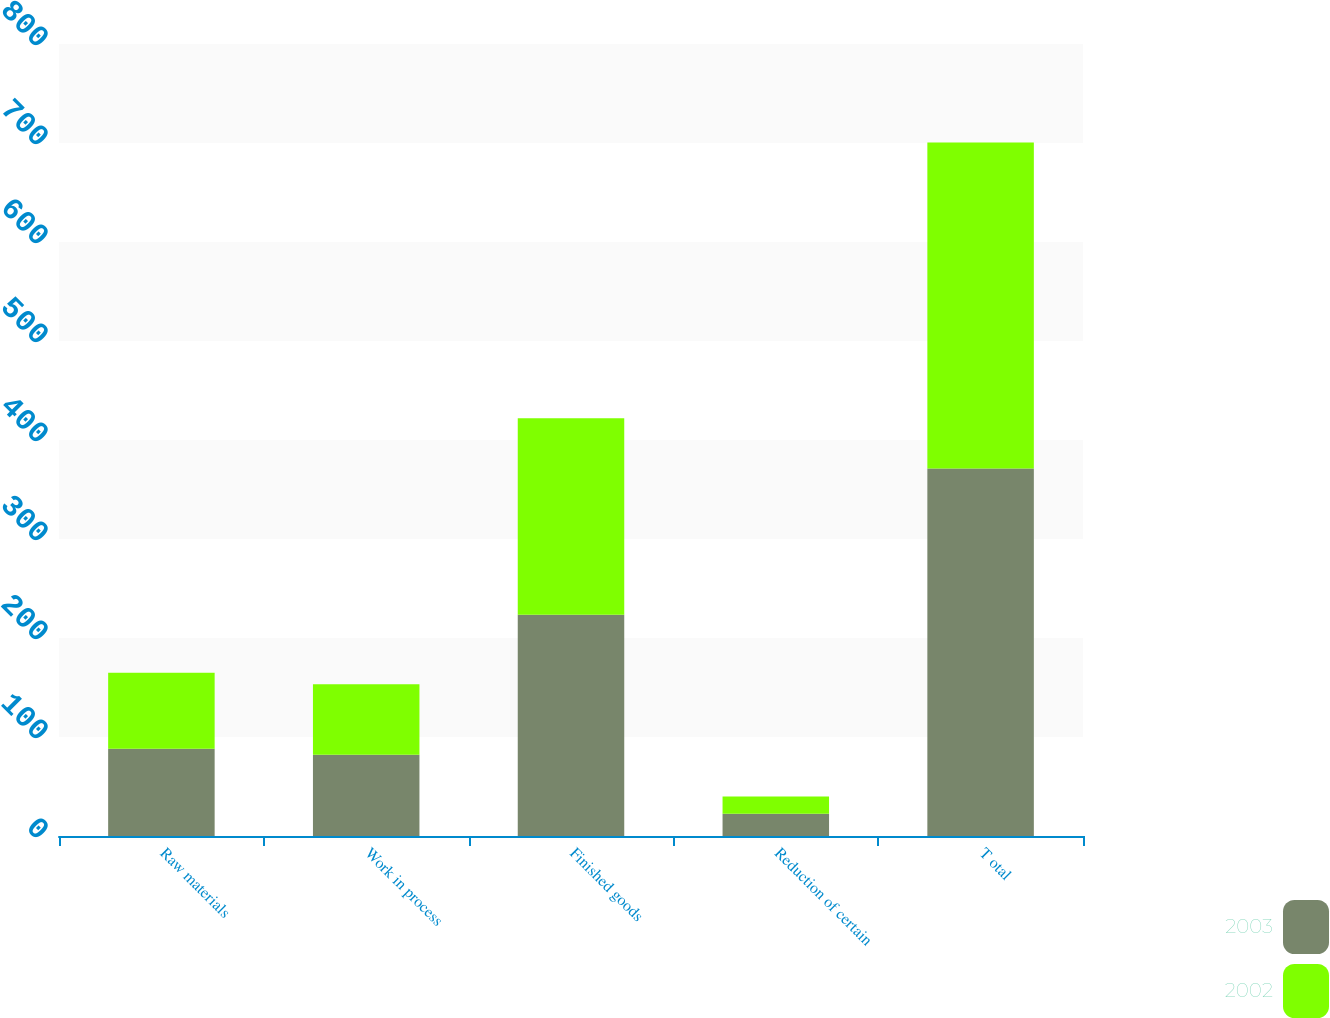Convert chart to OTSL. <chart><loc_0><loc_0><loc_500><loc_500><stacked_bar_chart><ecel><fcel>Raw materials<fcel>Work in process<fcel>Finished goods<fcel>Reduction of certain<fcel>T otal<nl><fcel>2003<fcel>88.1<fcel>82.1<fcel>223.6<fcel>22.6<fcel>371.2<nl><fcel>2002<fcel>76.9<fcel>71.3<fcel>198.4<fcel>17.2<fcel>329.4<nl></chart> 